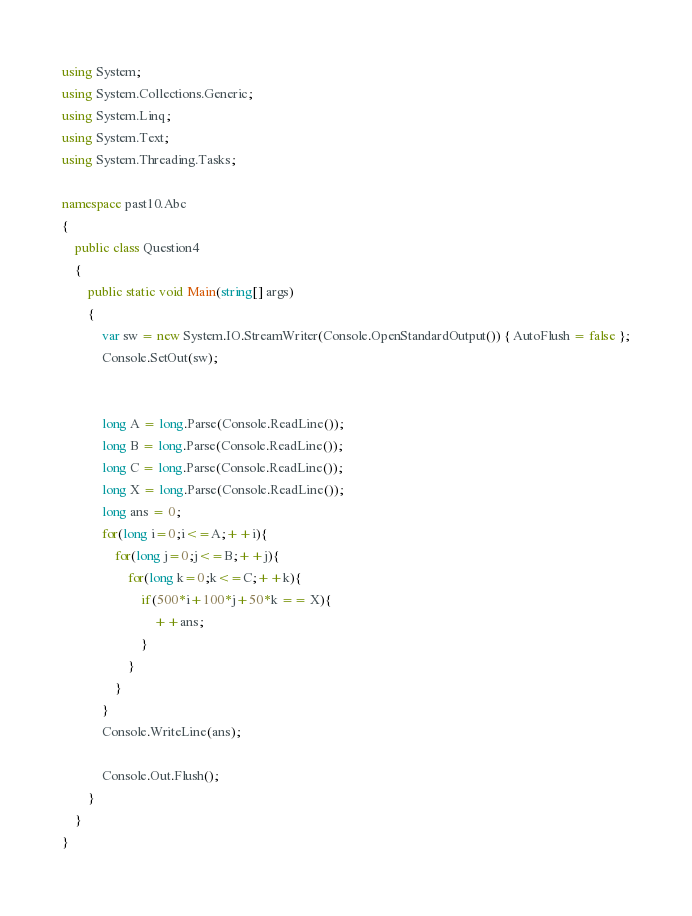Convert code to text. <code><loc_0><loc_0><loc_500><loc_500><_C#_>using System;
using System.Collections.Generic;
using System.Linq;
using System.Text;
using System.Threading.Tasks;

namespace past10.Abc
{
    public class Question4
    {
        public static void Main(string[] args)
        {
            var sw = new System.IO.StreamWriter(Console.OpenStandardOutput()) { AutoFlush = false };
            Console.SetOut(sw);


            long A = long.Parse(Console.ReadLine());
            long B = long.Parse(Console.ReadLine());
            long C = long.Parse(Console.ReadLine());
            long X = long.Parse(Console.ReadLine());
            long ans = 0;
            for(long i=0;i<=A;++i){
                for(long j=0;j<=B;++j){
                    for(long k=0;k<=C;++k){
                        if(500*i+100*j+50*k == X){
                            ++ans;
                        }
                    }
                }
            }
            Console.WriteLine(ans);

            Console.Out.Flush();
        }
    }
}</code> 